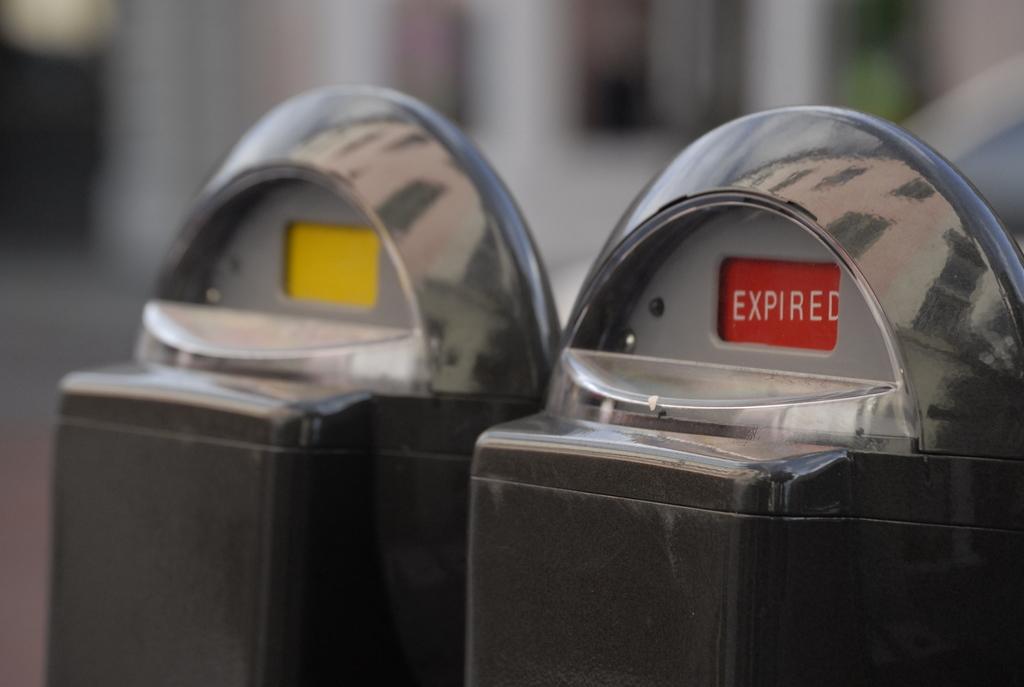What does it say in the red zone on the parking meter?
Your answer should be very brief. Expired. What is that which is expired?
Offer a terse response. Answering does not require reading text in the image. 